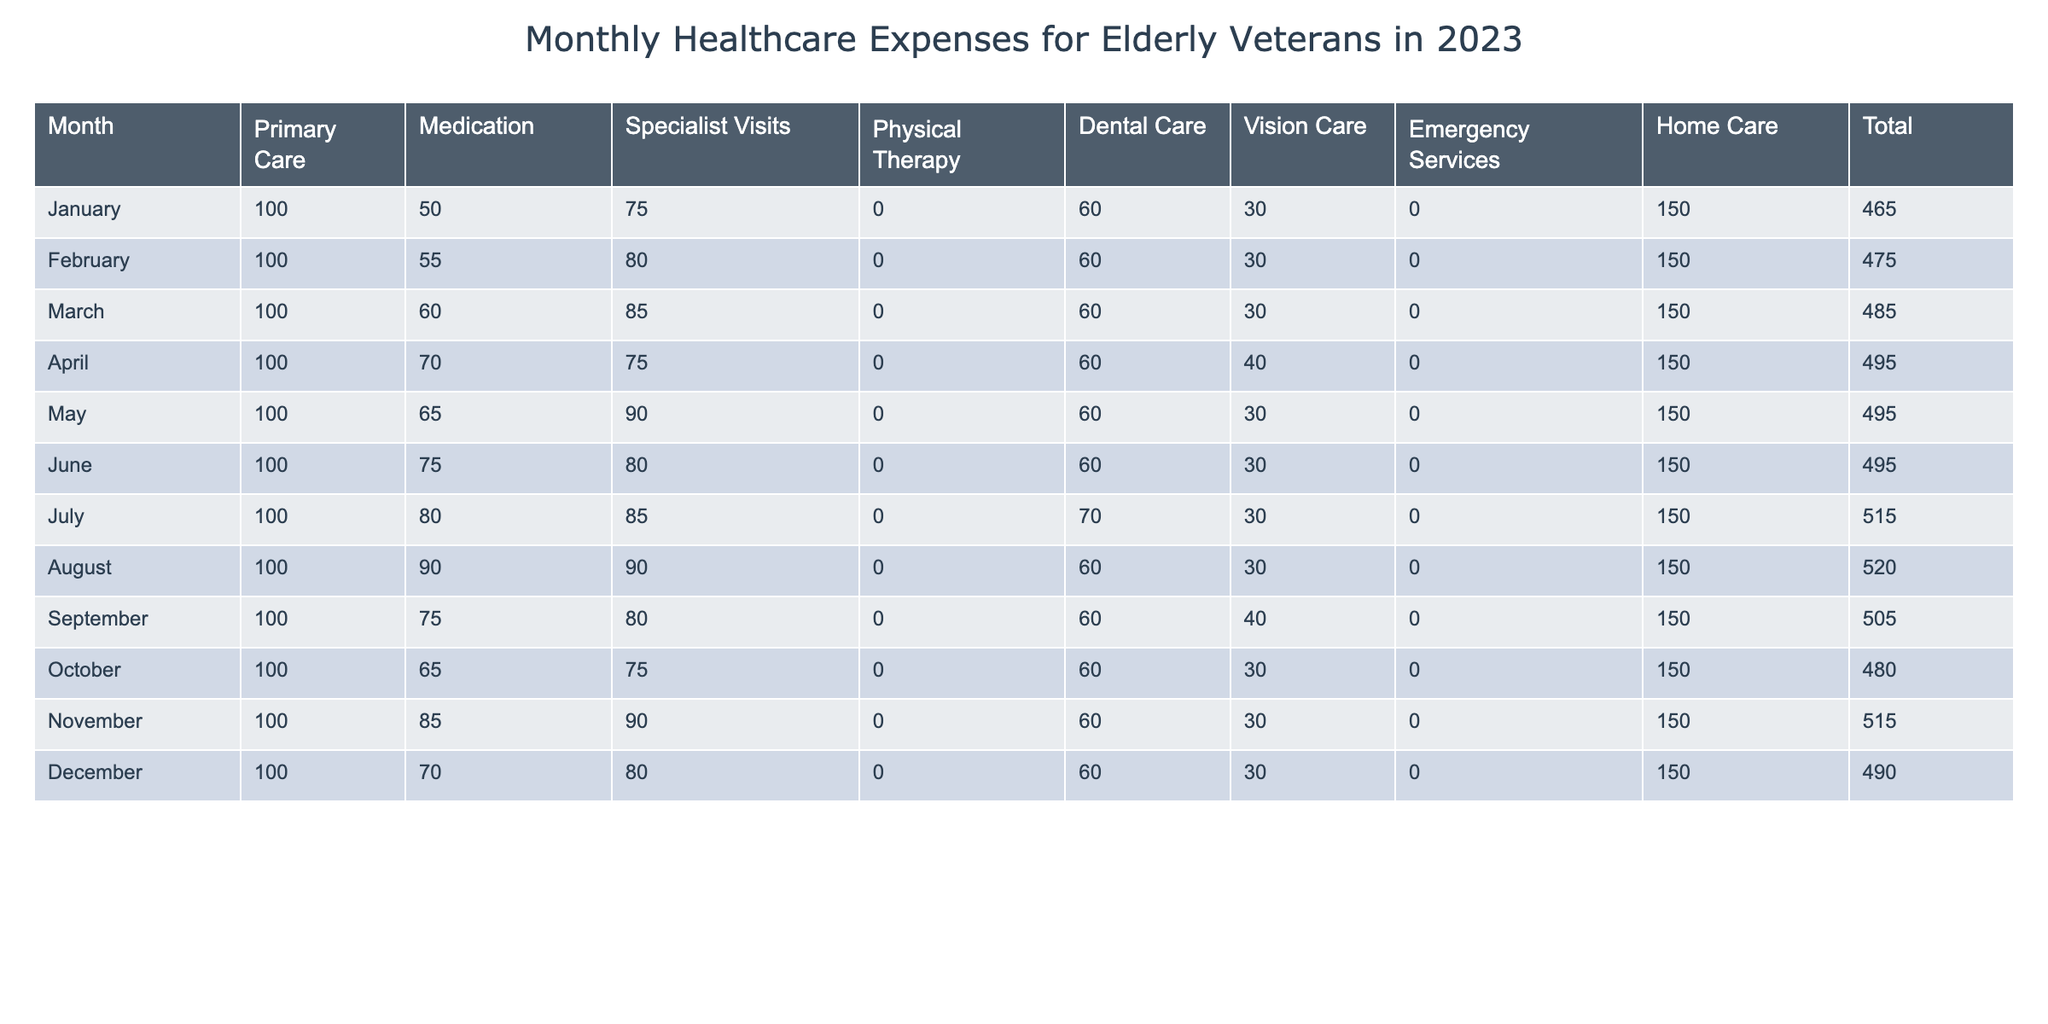What was the total healthcare expense for February? The table shows that the total healthcare expense for February is listed directly under the "Total" column for that month. It is 475.
Answer: 475 Which month had the highest medication expense? By checking the "Medication" column, I see that July has the highest medication expense of 80.
Answer: 80 What was the average total healthcare expense over the 12 months? To find the average total healthcare expense, I sum all the total expenses (465 + 475 + 485 + 495 + 495 + 495 + 515 + 520 + 505 + 480 + 515 + 490 = 5,830) and then divide by the number of months (12). The average is 5,830 / 12 = 485.83.
Answer: 485.83 Did any month have more than 500 total healthcare expenses? I analyze the "Total" column and find that July, August, November, and September all have total healthcare expenses that exceed 500. Therefore, the answer is yes.
Answer: Yes How much more was spent on specialist visits in March compared to January? Looking at the "Specialist Visits" column, March had 85 and January had 75. The difference is 85 - 75 = 10.
Answer: 10 What was the total expense for home care across all months? I sum the values in the "Home Care" column (150 for each month, and there are 12 months). Thus, the total is 150 * 12 = 1,800.
Answer: 1,800 Which month had the lowest total healthcare expense? By reviewing the "Total" column, I see that January has the lowest total of 465.
Answer: January What is the median of the total healthcare expenses for the year? To find the median, I first list the total expenses in order: 465, 475, 480, 485, 490, 495, 495, 495, 505, 515, 515, 520. There are 12 data points, so I take the average of the 6th and 7th values (495 and 495), which is (495 + 495) / 2 = 495.
Answer: 495 How many months had dental care expenses of 70 or more? I examine the "Dental Care" column and find that only July (70) and April (60) are above 70, which means there is 1 month that meets the criteria.
Answer: 1 Was the total healthcare expense for any month less than 470? By checking the "Total" column, I see that January (465) is the only month with a total below 470. Therefore, the answer is yes.
Answer: Yes 